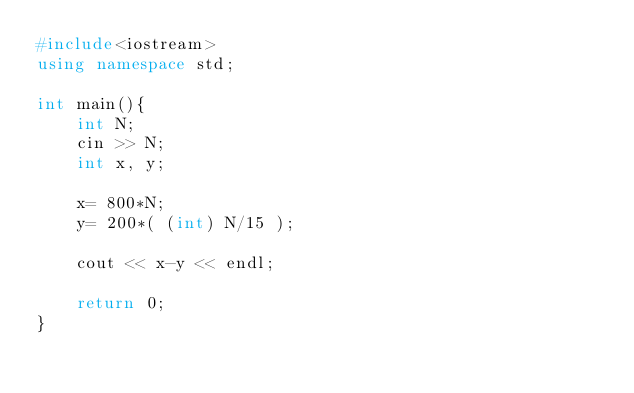Convert code to text. <code><loc_0><loc_0><loc_500><loc_500><_C++_>#include<iostream>
using namespace std;

int main(){
    int N;
    cin >> N;
    int x, y;

    x= 800*N;
    y= 200*( (int) N/15 );

    cout << x-y << endl;

    return 0;
}</code> 